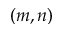<formula> <loc_0><loc_0><loc_500><loc_500>( m , n )</formula> 